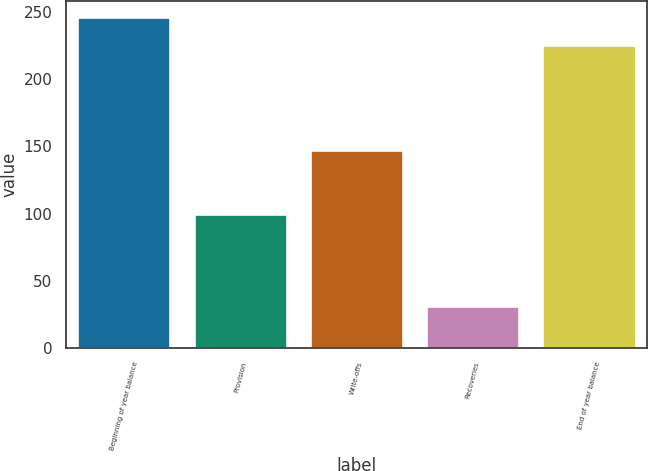Convert chart to OTSL. <chart><loc_0><loc_0><loc_500><loc_500><bar_chart><fcel>Beginning of year balance<fcel>Provision<fcel>Write-offs<fcel>Recoveries<fcel>End of year balance<nl><fcel>245.8<fcel>100<fcel>147<fcel>31<fcel>225<nl></chart> 